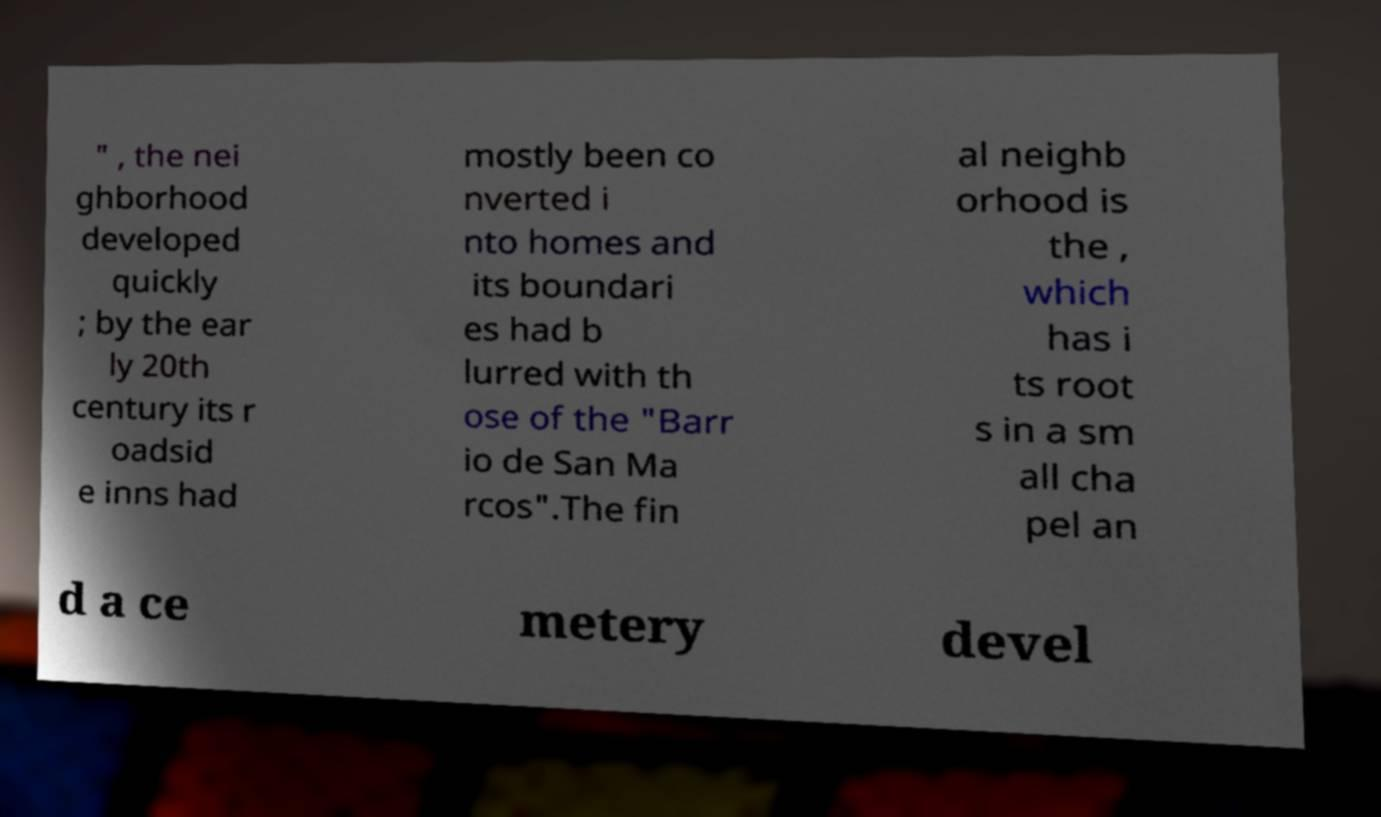Can you read and provide the text displayed in the image?This photo seems to have some interesting text. Can you extract and type it out for me? " , the nei ghborhood developed quickly ; by the ear ly 20th century its r oadsid e inns had mostly been co nverted i nto homes and its boundari es had b lurred with th ose of the "Barr io de San Ma rcos".The fin al neighb orhood is the , which has i ts root s in a sm all cha pel an d a ce metery devel 